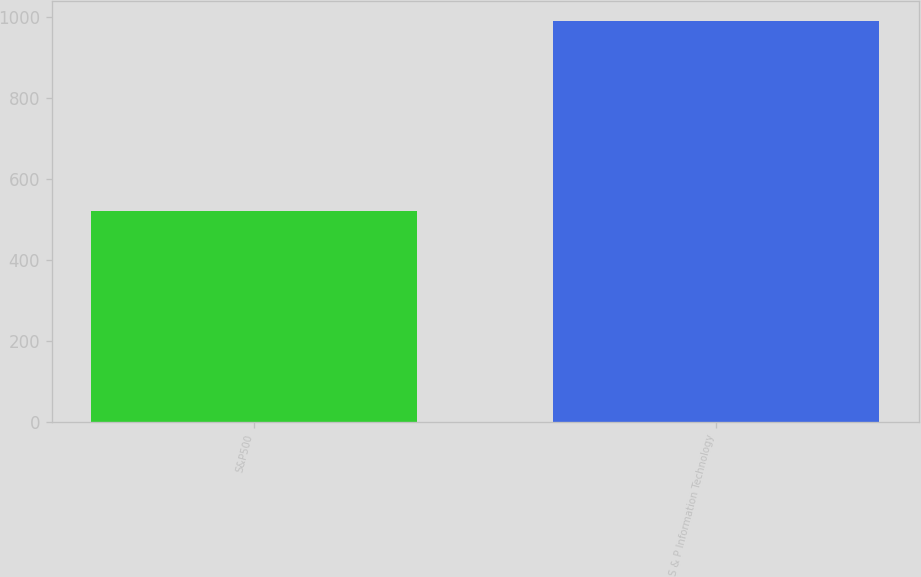Convert chart. <chart><loc_0><loc_0><loc_500><loc_500><bar_chart><fcel>S&P500<fcel>S & P Information Technology<nl><fcel>521.45<fcel>989.28<nl></chart> 